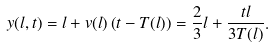Convert formula to latex. <formula><loc_0><loc_0><loc_500><loc_500>y ( l , t ) = l + v ( l ) \left ( t - T ( l ) \right ) = \frac { 2 } { 3 } l + \frac { t l } { 3 T ( l ) } .</formula> 